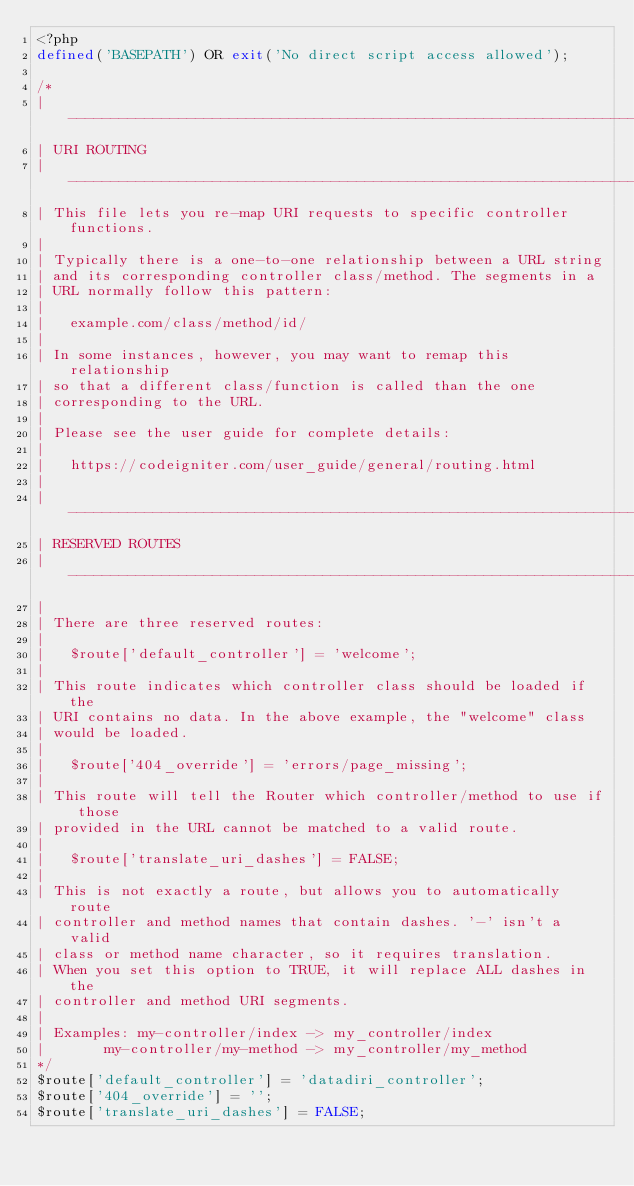Convert code to text. <code><loc_0><loc_0><loc_500><loc_500><_PHP_><?php
defined('BASEPATH') OR exit('No direct script access allowed');

/*
| -------------------------------------------------------------------------
| URI ROUTING
| -------------------------------------------------------------------------
| This file lets you re-map URI requests to specific controller functions.
|
| Typically there is a one-to-one relationship between a URL string
| and its corresponding controller class/method. The segments in a
| URL normally follow this pattern:
|
|	example.com/class/method/id/
|
| In some instances, however, you may want to remap this relationship
| so that a different class/function is called than the one
| corresponding to the URL.
|
| Please see the user guide for complete details:
|
|	https://codeigniter.com/user_guide/general/routing.html
|
| -------------------------------------------------------------------------
| RESERVED ROUTES
| -------------------------------------------------------------------------
|
| There are three reserved routes:
|
|	$route['default_controller'] = 'welcome';
|
| This route indicates which controller class should be loaded if the
| URI contains no data. In the above example, the "welcome" class
| would be loaded.
|
|	$route['404_override'] = 'errors/page_missing';
|
| This route will tell the Router which controller/method to use if those
| provided in the URL cannot be matched to a valid route.
|
|	$route['translate_uri_dashes'] = FALSE;
|
| This is not exactly a route, but allows you to automatically route
| controller and method names that contain dashes. '-' isn't a valid
| class or method name character, so it requires translation.
| When you set this option to TRUE, it will replace ALL dashes in the
| controller and method URI segments.
|
| Examples:	my-controller/index	-> my_controller/index
|		my-controller/my-method	-> my_controller/my_method
*/
$route['default_controller'] = 'datadiri_controller';
$route['404_override'] = '';
$route['translate_uri_dashes'] = FALSE;
</code> 